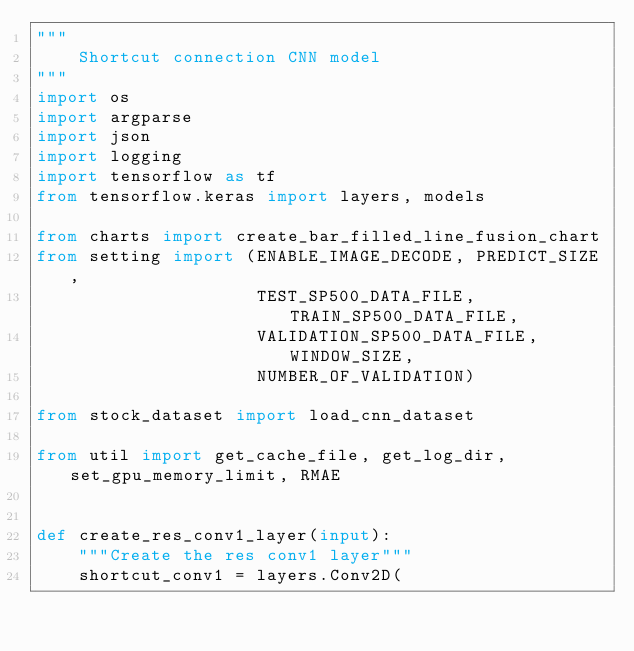Convert code to text. <code><loc_0><loc_0><loc_500><loc_500><_Python_>"""
    Shortcut connection CNN model
"""
import os
import argparse
import json
import logging
import tensorflow as tf
from tensorflow.keras import layers, models

from charts import create_bar_filled_line_fusion_chart
from setting import (ENABLE_IMAGE_DECODE, PREDICT_SIZE,
                     TEST_SP500_DATA_FILE, TRAIN_SP500_DATA_FILE,
                     VALIDATION_SP500_DATA_FILE, WINDOW_SIZE,
                     NUMBER_OF_VALIDATION)

from stock_dataset import load_cnn_dataset

from util import get_cache_file, get_log_dir, set_gpu_memory_limit, RMAE


def create_res_conv1_layer(input):
    """Create the res conv1 layer"""
    shortcut_conv1 = layers.Conv2D(</code> 